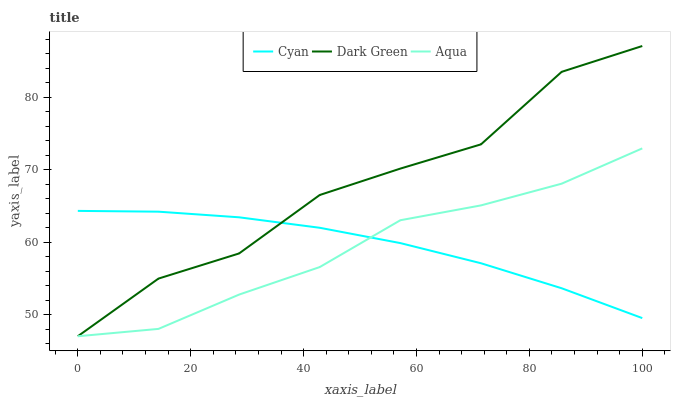Does Aqua have the minimum area under the curve?
Answer yes or no. Yes. Does Dark Green have the maximum area under the curve?
Answer yes or no. Yes. Does Dark Green have the minimum area under the curve?
Answer yes or no. No. Does Aqua have the maximum area under the curve?
Answer yes or no. No. Is Cyan the smoothest?
Answer yes or no. Yes. Is Dark Green the roughest?
Answer yes or no. Yes. Is Aqua the smoothest?
Answer yes or no. No. Is Aqua the roughest?
Answer yes or no. No. Does Aqua have the lowest value?
Answer yes or no. Yes. Does Dark Green have the highest value?
Answer yes or no. Yes. Does Aqua have the highest value?
Answer yes or no. No. Does Dark Green intersect Cyan?
Answer yes or no. Yes. Is Dark Green less than Cyan?
Answer yes or no. No. Is Dark Green greater than Cyan?
Answer yes or no. No. 